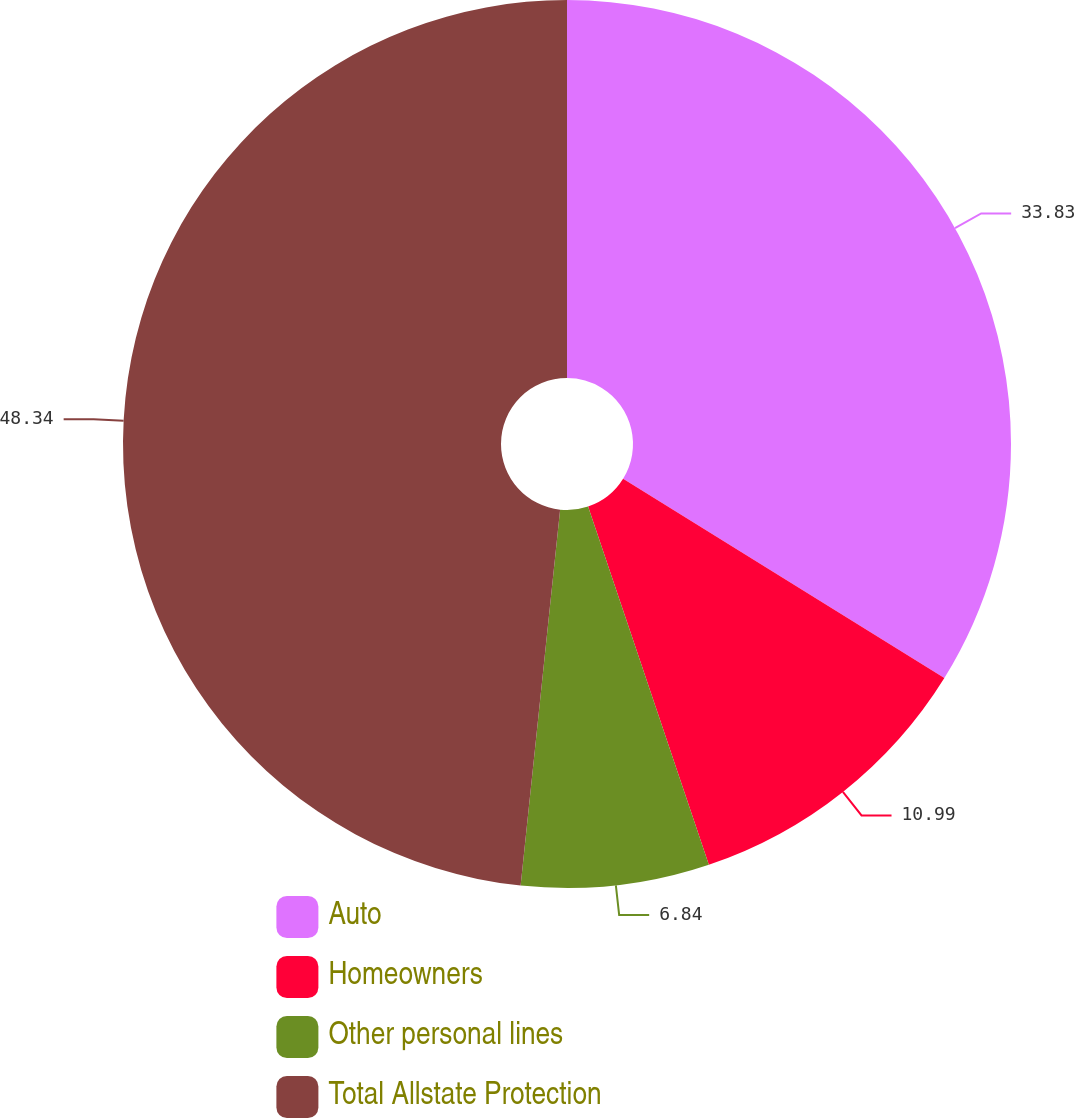<chart> <loc_0><loc_0><loc_500><loc_500><pie_chart><fcel>Auto<fcel>Homeowners<fcel>Other personal lines<fcel>Total Allstate Protection<nl><fcel>33.83%<fcel>10.99%<fcel>6.84%<fcel>48.33%<nl></chart> 